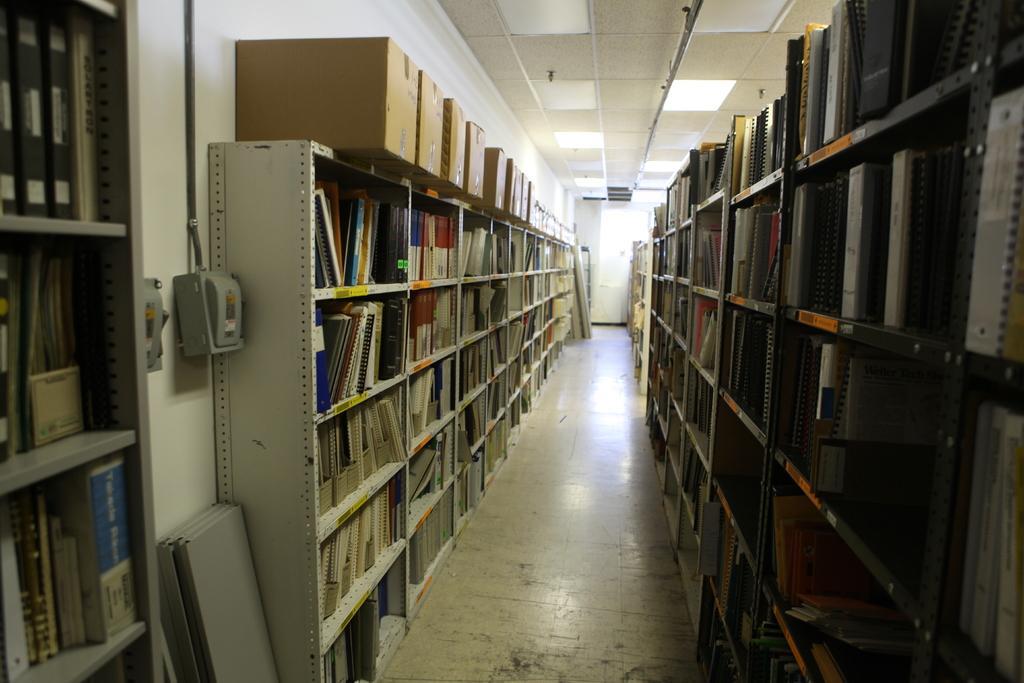Can you describe this image briefly? In this image we can see books arranged in the racks of cupboards, wooden planks on the floor, electric boards, pipelines, cardboard cartons and electric lights to the roof. 